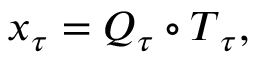<formula> <loc_0><loc_0><loc_500><loc_500>x _ { \ u { \tau } } = Q _ { \ u { \tau } } \circ T _ { \ u { \tau } } ,</formula> 